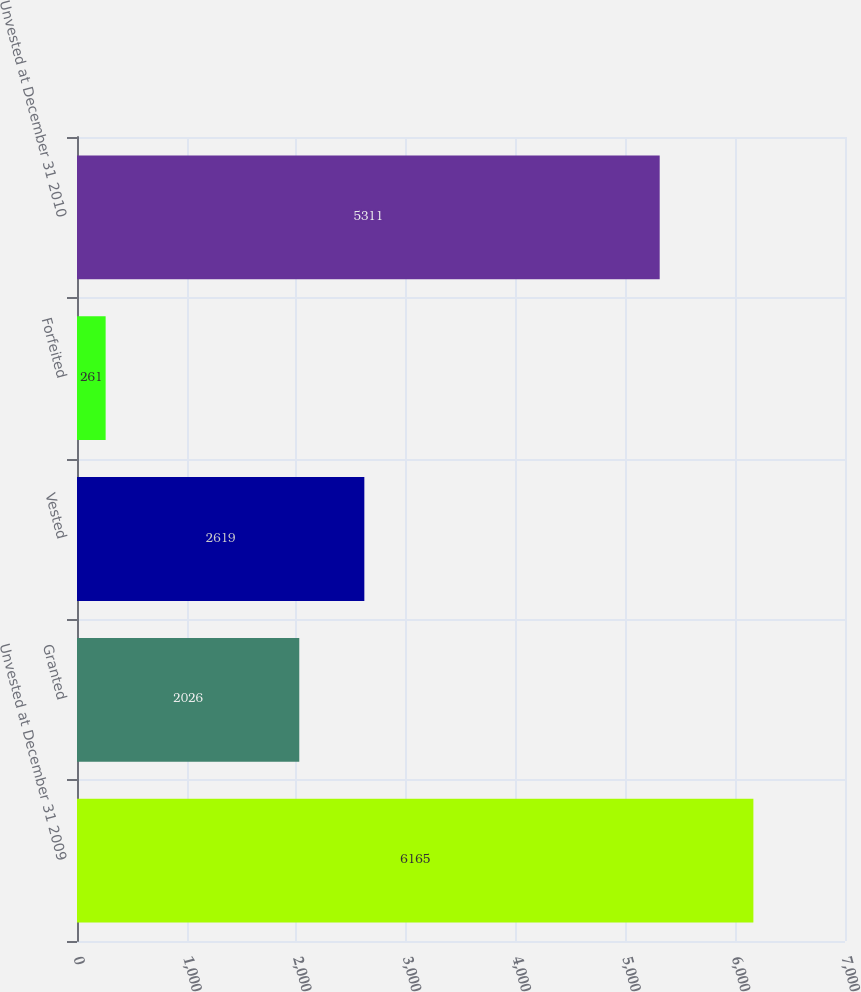Convert chart to OTSL. <chart><loc_0><loc_0><loc_500><loc_500><bar_chart><fcel>Unvested at December 31 2009<fcel>Granted<fcel>Vested<fcel>Forfeited<fcel>Unvested at December 31 2010<nl><fcel>6165<fcel>2026<fcel>2619<fcel>261<fcel>5311<nl></chart> 